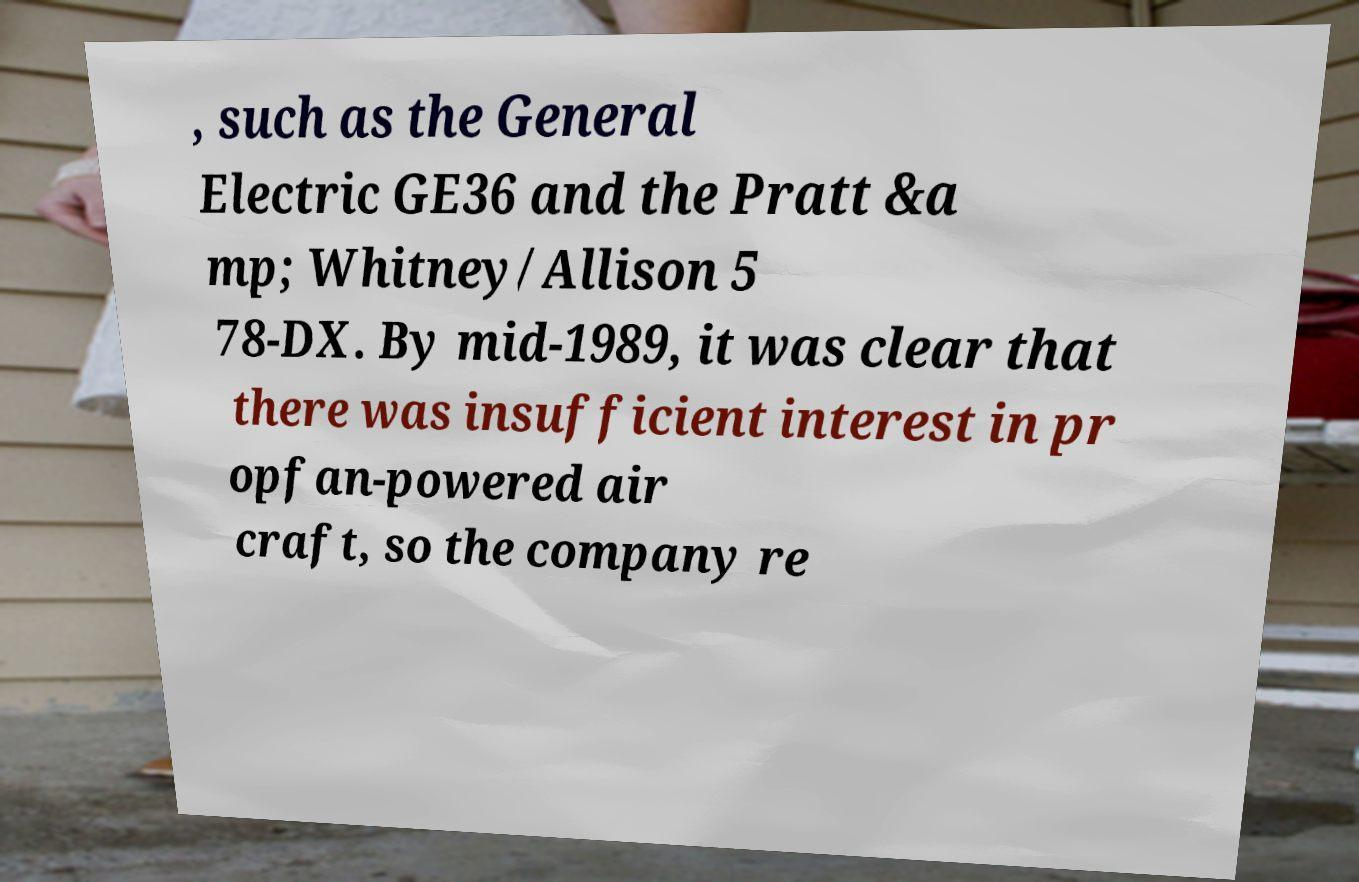For documentation purposes, I need the text within this image transcribed. Could you provide that? , such as the General Electric GE36 and the Pratt &a mp; Whitney/Allison 5 78-DX. By mid-1989, it was clear that there was insufficient interest in pr opfan-powered air craft, so the company re 